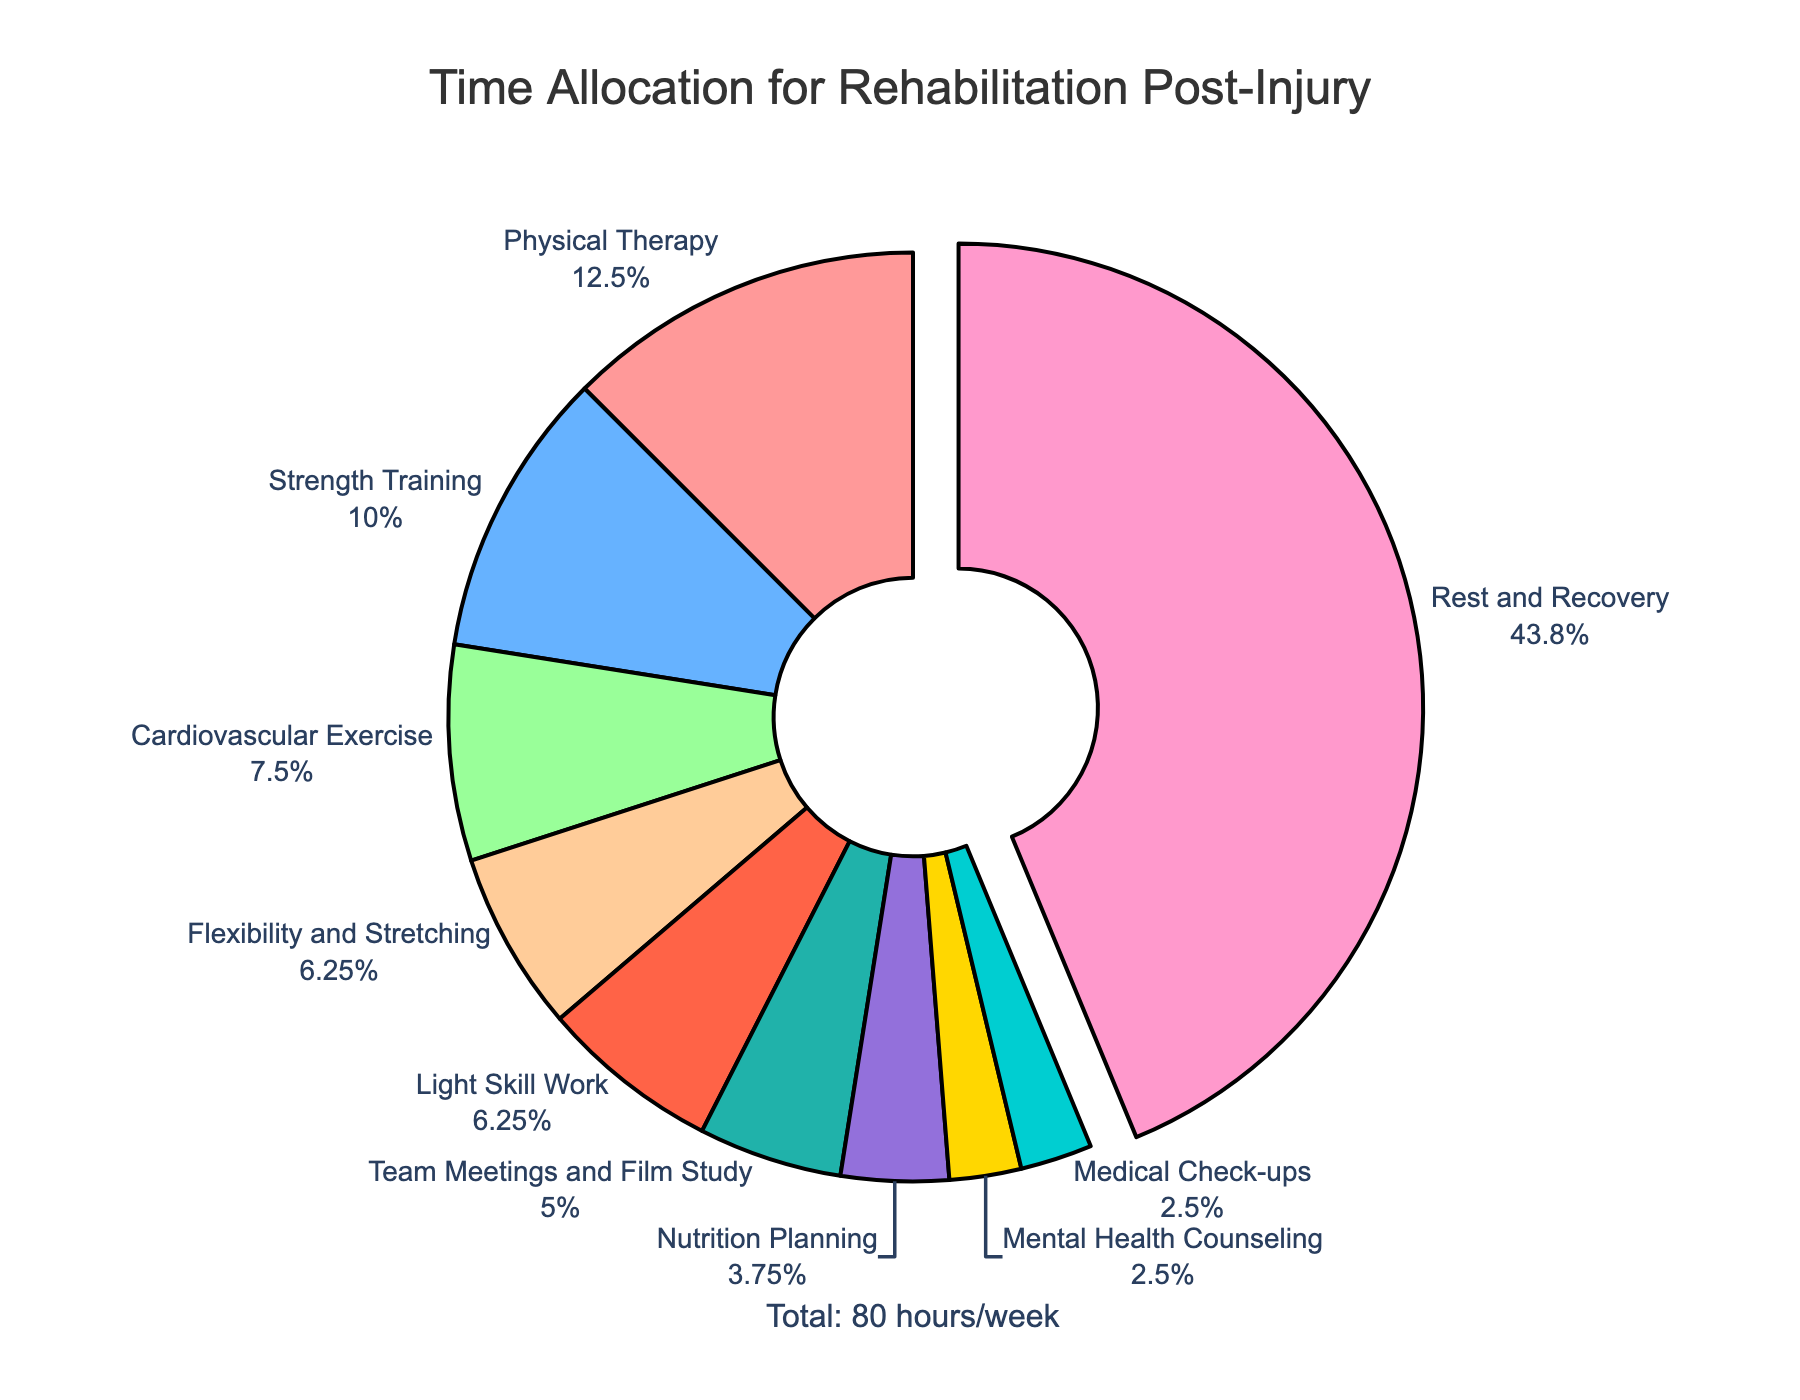What's the largest time allocation activity in the rehabilitation process? The activity with the largest time allocation is the one with the highest percentage in the pie chart. Physical Therapy has the largest slice.
Answer: Rest and Recovery How many hours per week are spent on activities related to mental health and medical check-ups combined? Sum the hours allocated for Mental Health Counseling and Medical Check-ups: 2 + 2 = 4
Answer: 4 hours Which activity has more hours per week, Cardiovascular Exercise or Flexibility and Stretching? Compare the hours allotted for Cardiovascular Exercise (6 hours) and Flexibility and Stretching (5 hours) directly.
Answer: Cardiovascular Exercise What percentage of time is allocated to Light Skill Work, approximately? In the pie chart, find the percentage associated with Light Skill Work.
Answer: Around 7.94% How many activities are allocated less than 10 hours per week? Count the activities in the pie chart that have under 10 hours per week. This includes Strength Training, Cardiovascular Exercise, Flexibility and Stretching, Mental Health Counseling, Nutrition Planning, Team Meetings and Film Study, Light Skill Work, and Medical Check-ups.
Answer: 8 activities Is the combined time spent on Nutrition Planning and Mental Health Counseling greater than that for Team Meetings and Film Study? Sum the hours for Nutrition Planning (3) and Mental Health Counseling (2), then compare with Team Meetings and Film Study (4): 3 + 2 = 5, which is greater than 4.
Answer: Yes What is the total time allocated per week for all the activities listed? The total is mentioned in the annotation of the chart: 10 + 8 + 6 + 5 + 35 + 2 + 3 + 4 + 5 + 2 = 80 hours/week.
Answer: 80 hours/week Which activity has the least time allocated, and how much time is it? The smallest slice in the pie chart represents the activity with the least time. Both Mental Health Counseling and Medical Check-ups are the smallest.
Answer: Mental Health Counseling and Medical Check-ups, 2 hours each Compare the total time spent on Physical Therapy and Strength Training. How does it relate to the time spent on Rest and Recovery? Sum Physical Therapy (10) and Strength Training (8): 10 + 8 = 18. Compare 18 hours with Rest and Recovery (35 hours). Rest and Recovery has significantly more time.
Answer: Rest and Recovery has more time allocated What fraction of the rehabilitation time is spent on Rest and Recovery? The total time is 80 hours/week, with 35 hours allocated to Rest and Recovery. The fraction is 35/80, which simplifies to 7/16.
Answer: 7/16 